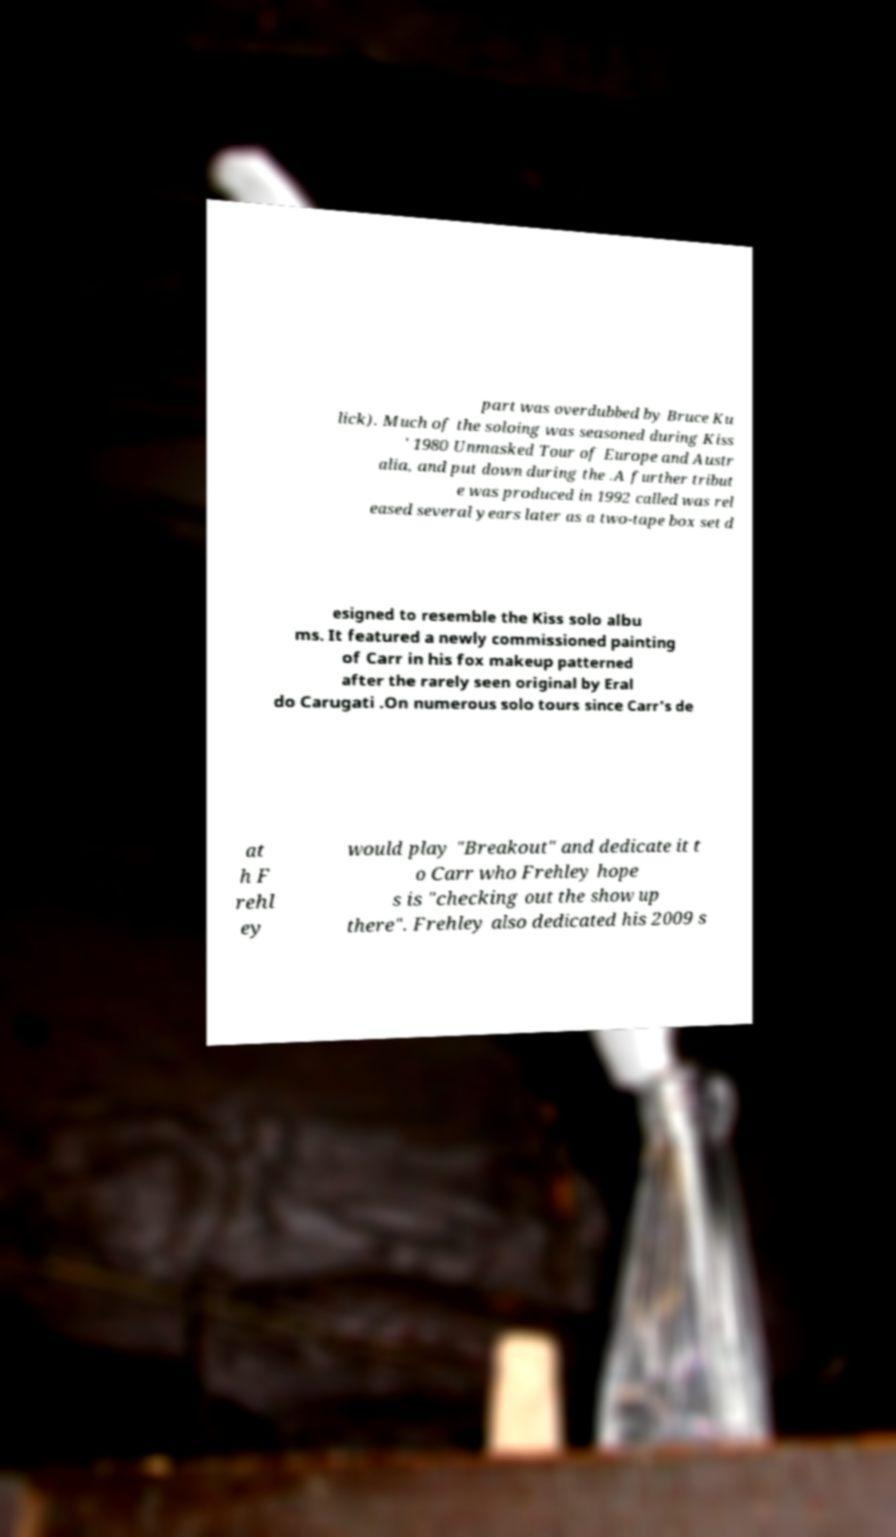What messages or text are displayed in this image? I need them in a readable, typed format. part was overdubbed by Bruce Ku lick). Much of the soloing was seasoned during Kiss ' 1980 Unmasked Tour of Europe and Austr alia, and put down during the .A further tribut e was produced in 1992 called was rel eased several years later as a two-tape box set d esigned to resemble the Kiss solo albu ms. It featured a newly commissioned painting of Carr in his fox makeup patterned after the rarely seen original by Eral do Carugati .On numerous solo tours since Carr's de at h F rehl ey would play "Breakout" and dedicate it t o Carr who Frehley hope s is "checking out the show up there". Frehley also dedicated his 2009 s 